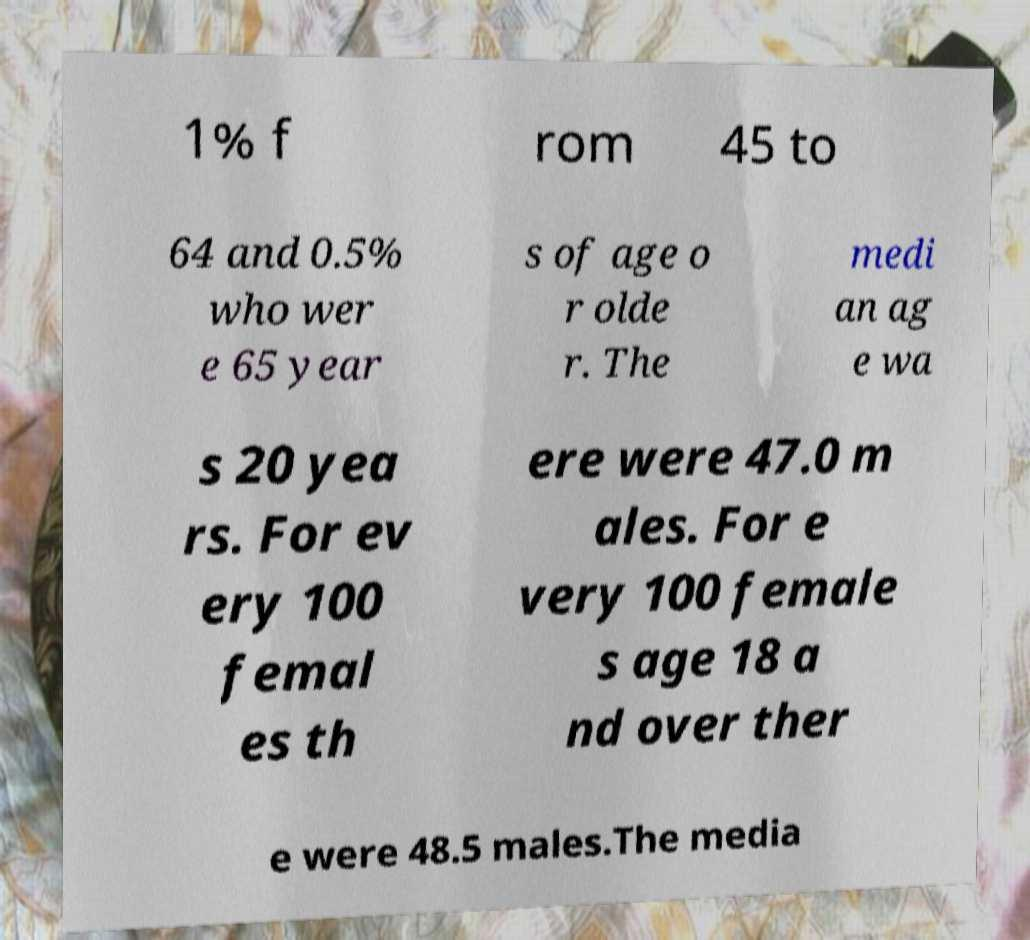There's text embedded in this image that I need extracted. Can you transcribe it verbatim? 1% f rom 45 to 64 and 0.5% who wer e 65 year s of age o r olde r. The medi an ag e wa s 20 yea rs. For ev ery 100 femal es th ere were 47.0 m ales. For e very 100 female s age 18 a nd over ther e were 48.5 males.The media 